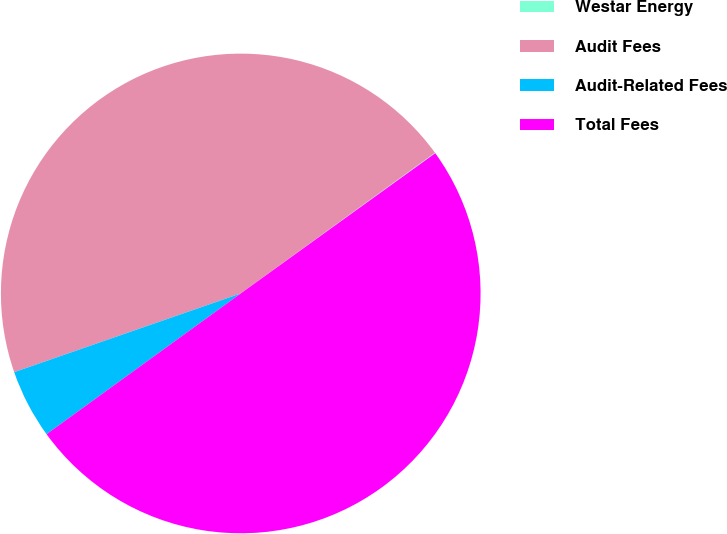<chart> <loc_0><loc_0><loc_500><loc_500><pie_chart><fcel>Westar Energy<fcel>Audit Fees<fcel>Audit-Related Fees<fcel>Total Fees<nl><fcel>0.04%<fcel>45.34%<fcel>4.66%<fcel>49.96%<nl></chart> 